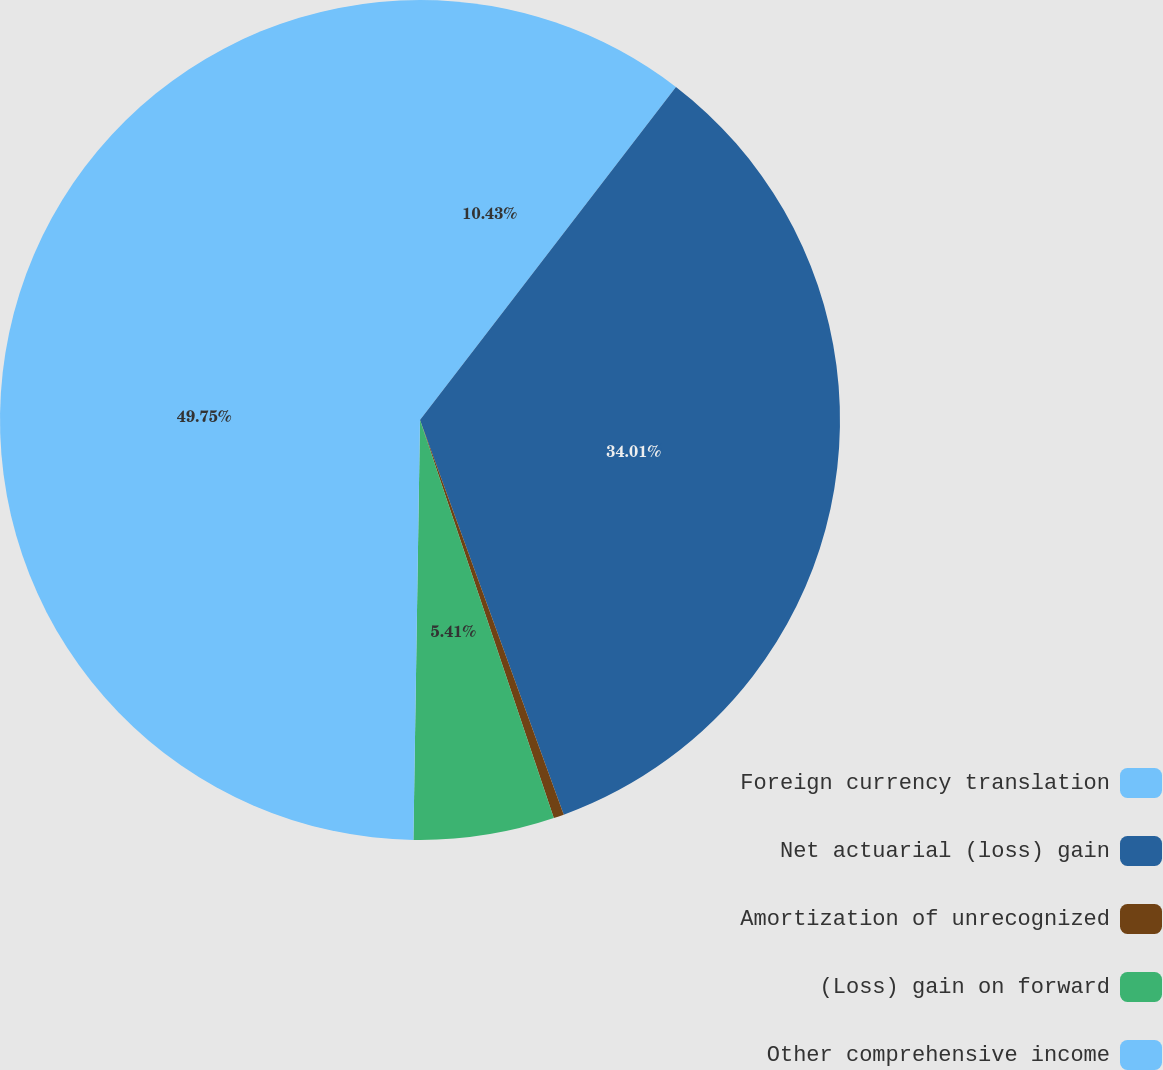<chart> <loc_0><loc_0><loc_500><loc_500><pie_chart><fcel>Foreign currency translation<fcel>Net actuarial (loss) gain<fcel>Amortization of unrecognized<fcel>(Loss) gain on forward<fcel>Other comprehensive income<nl><fcel>10.43%<fcel>34.01%<fcel>0.4%<fcel>5.41%<fcel>49.75%<nl></chart> 